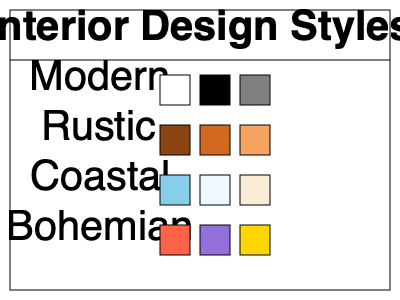Which interior design style is typically associated with a color scheme consisting of white, black, and gray tones? To determine the interior design style associated with a color scheme of white, black, and gray tones, let's analyze the color palettes presented for each style:

1. Modern: The color scheme shows white (#FFFFFF), black (#000000), and gray (#808080) rectangles.
2. Rustic: The color scheme displays various shades of brown (#8B4513, #D2691E, #F4A460).
3. Coastal: The color palette includes light blue (#87CEEB), very light blue (#F0F8FF), and light beige (#FAEBD7).
4. Bohemian: The color scheme shows bright red (#FF6347), purple (#9370DB), and gold (#FFD700).

Among these options, only the Modern style features a color palette consisting of white, black, and gray tones. This color scheme is characteristic of the Modern design style, which often emphasizes clean lines, minimalism, and a monochromatic color palette.
Answer: Modern 